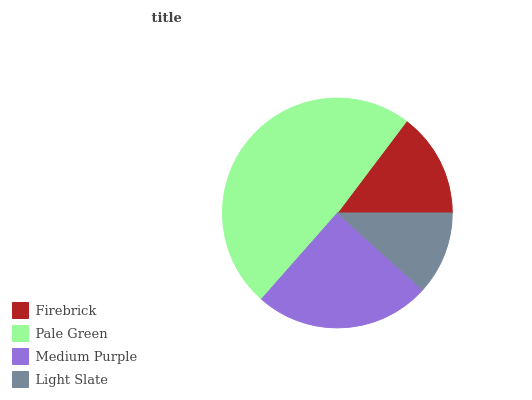Is Light Slate the minimum?
Answer yes or no. Yes. Is Pale Green the maximum?
Answer yes or no. Yes. Is Medium Purple the minimum?
Answer yes or no. No. Is Medium Purple the maximum?
Answer yes or no. No. Is Pale Green greater than Medium Purple?
Answer yes or no. Yes. Is Medium Purple less than Pale Green?
Answer yes or no. Yes. Is Medium Purple greater than Pale Green?
Answer yes or no. No. Is Pale Green less than Medium Purple?
Answer yes or no. No. Is Medium Purple the high median?
Answer yes or no. Yes. Is Firebrick the low median?
Answer yes or no. Yes. Is Light Slate the high median?
Answer yes or no. No. Is Light Slate the low median?
Answer yes or no. No. 